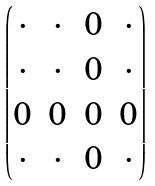<formula> <loc_0><loc_0><loc_500><loc_500>\begin{pmatrix} \cdot & \cdot & 0 & \cdot \\ \cdot & \cdot & 0 & \cdot \\ 0 & 0 & 0 & 0 \\ \cdot & \cdot & 0 & \cdot \end{pmatrix}</formula> 